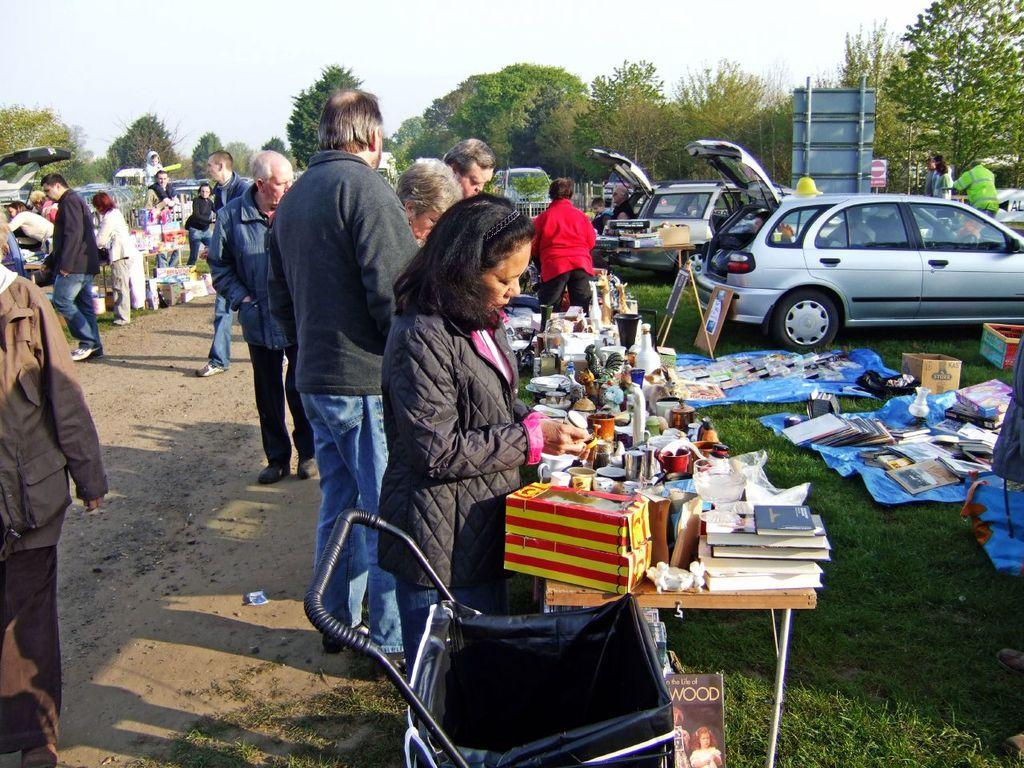What is the main subject of the image? There is a group of people on the ground in the image. What type of terrain is visible in the image? Grass is present in the image. What objects can be seen in the image related to transportation? Vehicles are visible in the image. What type of objects are present in the image that might be used for carrying or storing items? There are carts, boxes, and books present in the image. What is visible in the background of the image? The sky is visible in the background of the image. What type of vegetation is present in the image? Trees are present in the image. What type of seed is being planted by the people in the image? There is no indication in the image that the people are planting seeds or engaging in any agricultural activity. 